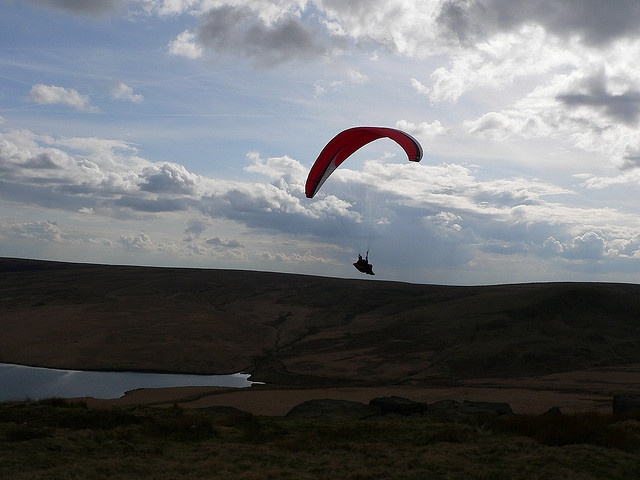Describe the objects in this image and their specific colors. I can see kite in gray, maroon, black, and lightgray tones and people in gray and black tones in this image. 